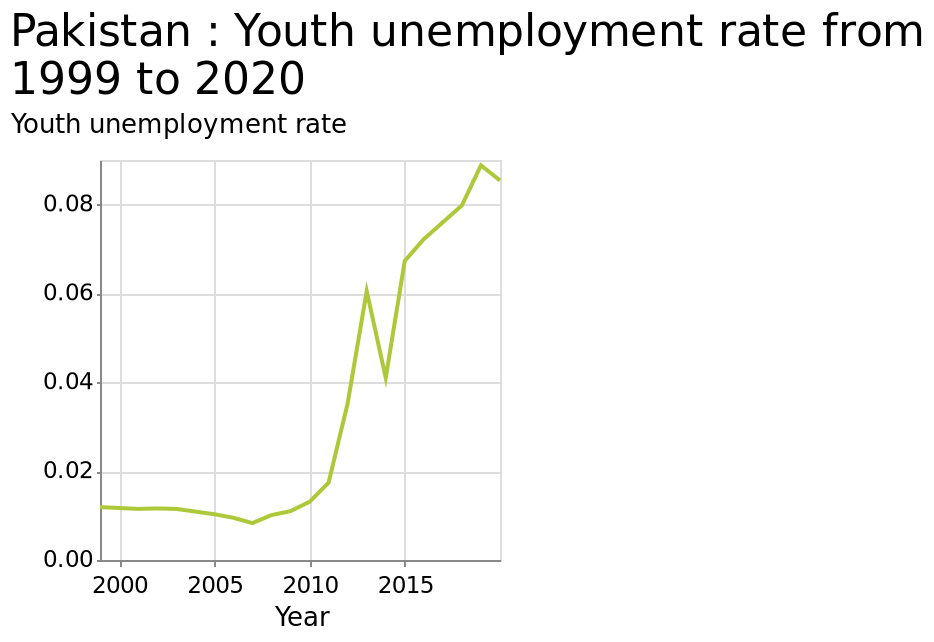<image>
What is the time period covered in the graph for the unemployment rate in Mongolia? The graph covers the years from 1999 to 2020. 